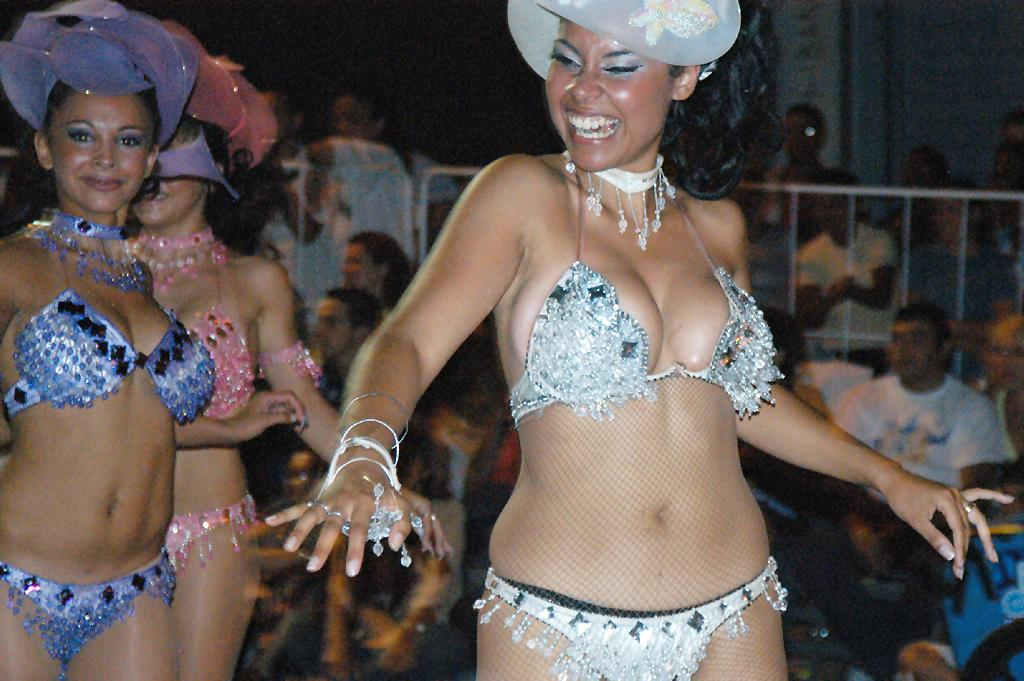How many women are in the image? There are three women in the image. What are the women doing in the image? The women are dancing. Can you describe the clothing of the women in the image? The women are wearing different clothes. What is happening behind the women in the image? There is a crowd behind the women. What is the crowd doing in the image? The crowd is watching the women's performance. What type of cracker is being used as a prop in the women's dance performance? There is no cracker present in the image, and no props are mentioned in the provided facts. 